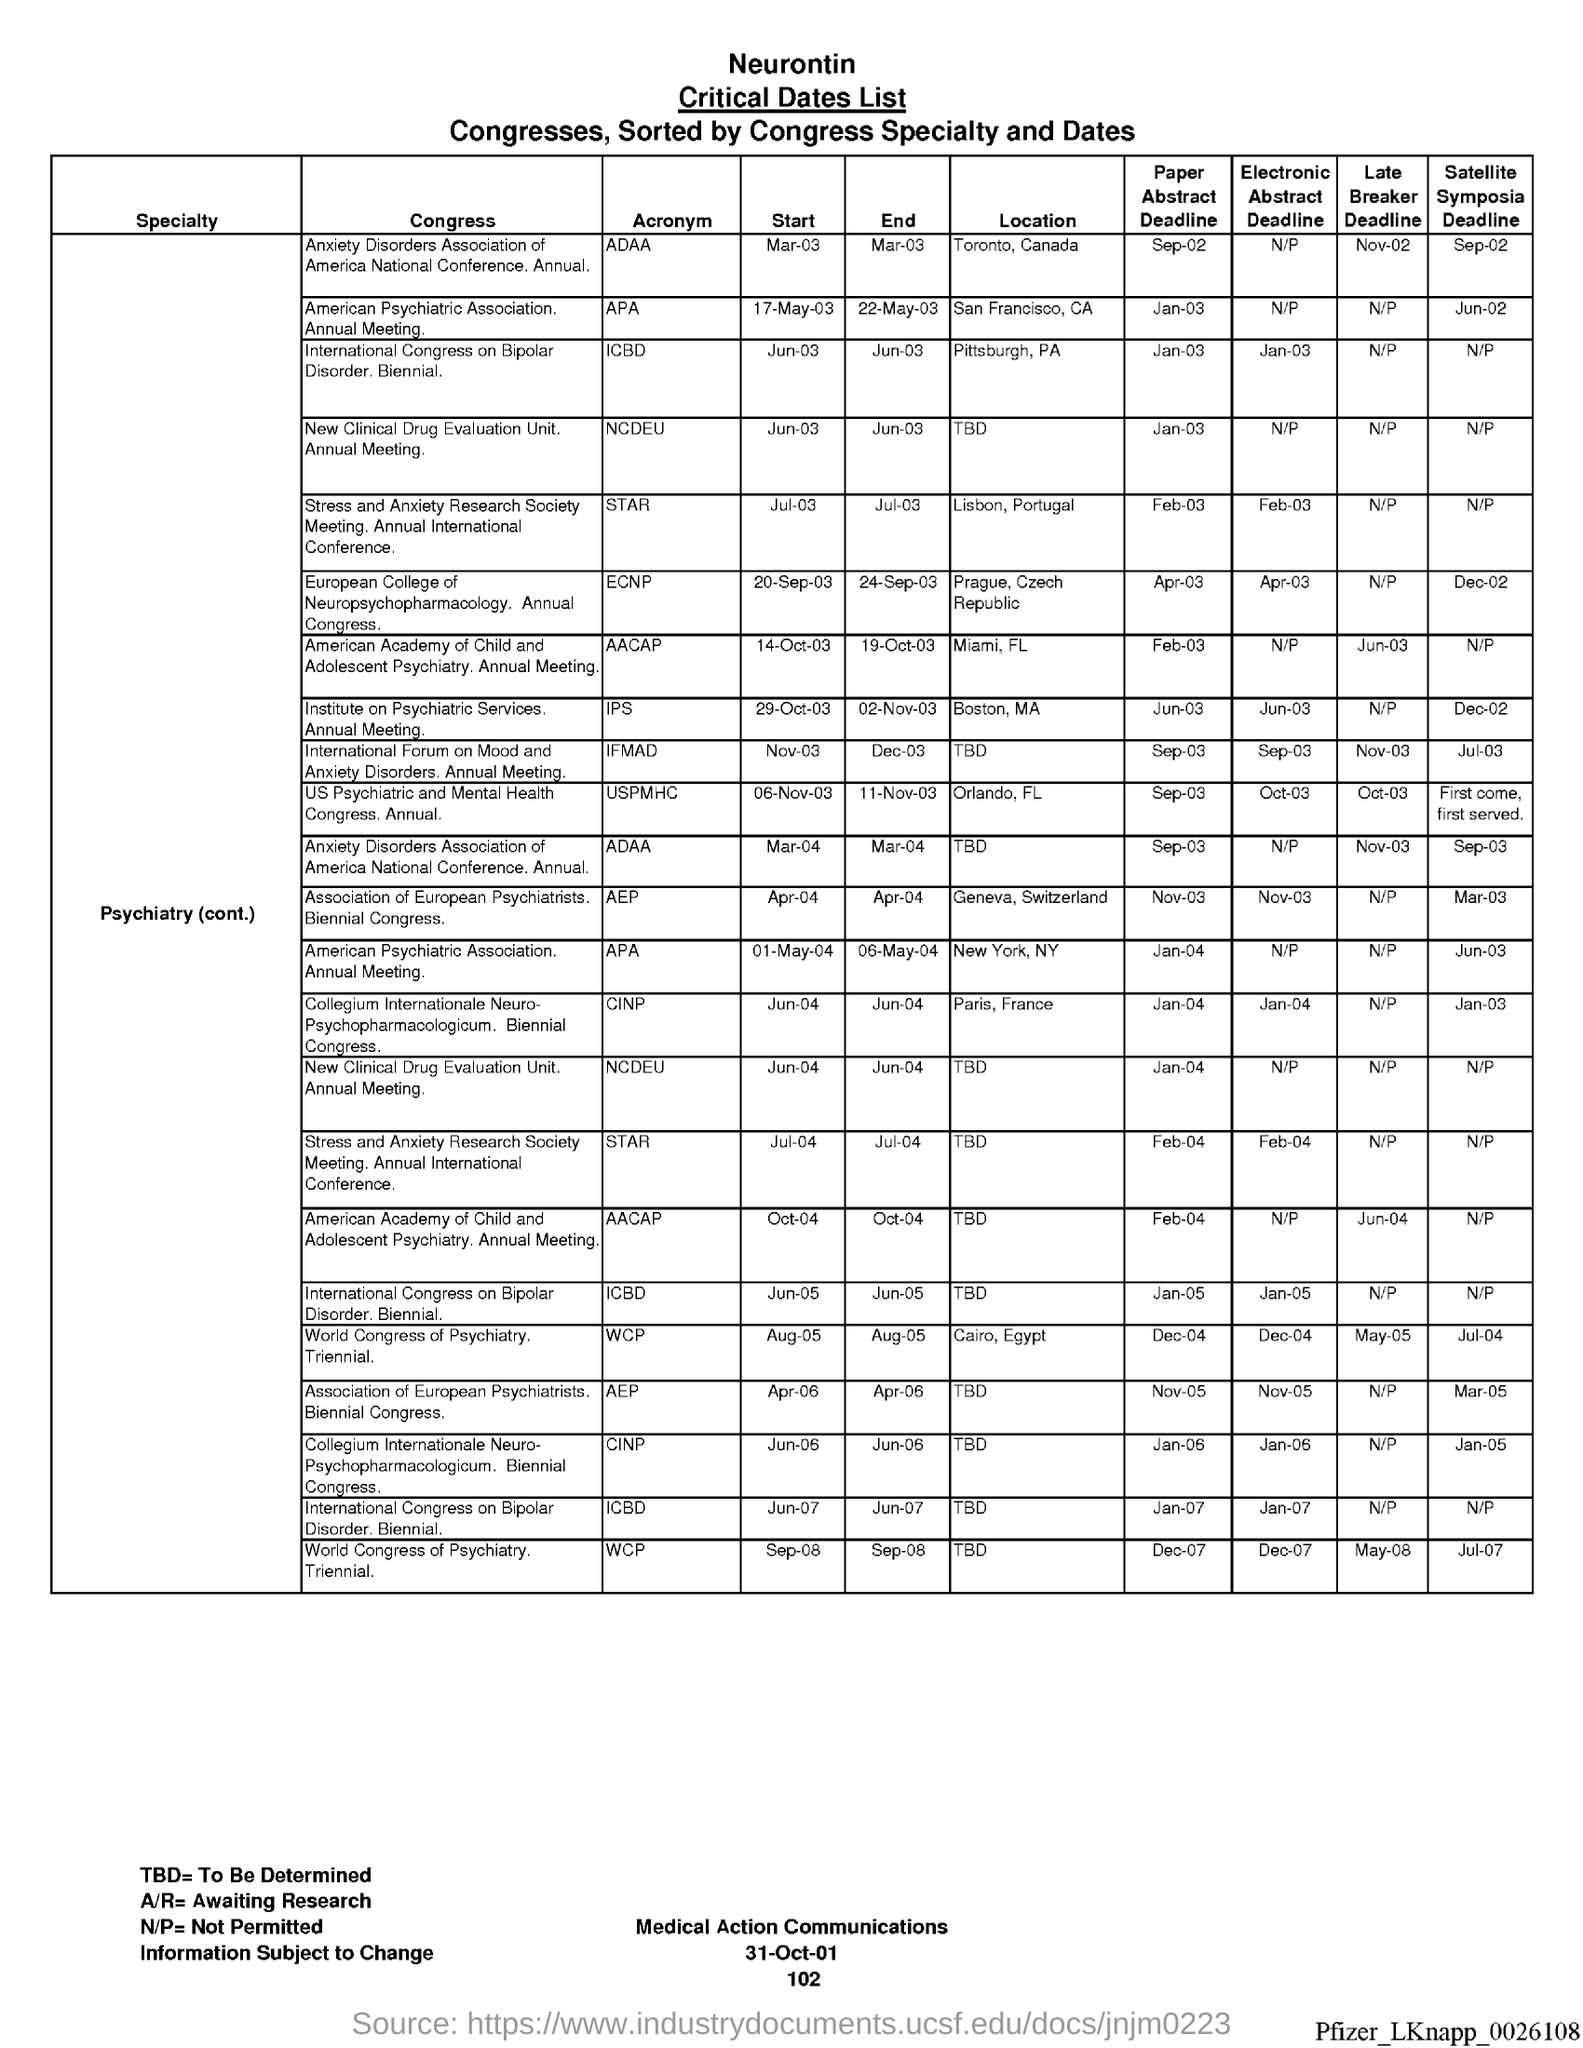What is the date at bottom of the page?
Keep it short and to the point. 31-Oct-01. What is the page number below date?
Make the answer very short. 102. What is tbd= ?
Make the answer very short. To be determined. What is a/r= ?
Your answer should be compact. Awaiting Research. What is n/p equals to ?
Ensure brevity in your answer.  Not permitted. 